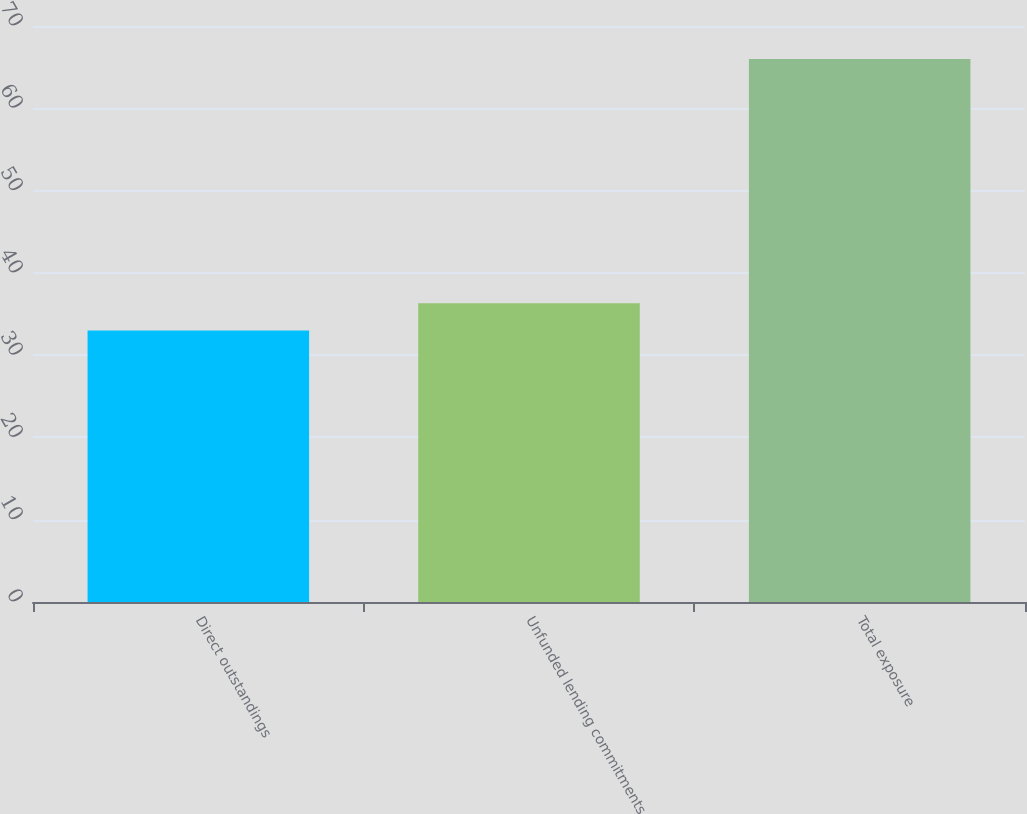<chart> <loc_0><loc_0><loc_500><loc_500><bar_chart><fcel>Direct outstandings<fcel>Unfunded lending commitments<fcel>Total exposure<nl><fcel>33<fcel>36.3<fcel>66<nl></chart> 